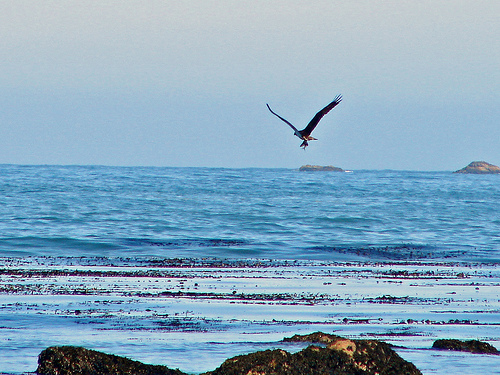<image>
Can you confirm if the bird is on the ocean? No. The bird is not positioned on the ocean. They may be near each other, but the bird is not supported by or resting on top of the ocean. Is there a bird on the water? No. The bird is not positioned on the water. They may be near each other, but the bird is not supported by or resting on top of the water. Where is the bird in relation to the water? Is it above the water? Yes. The bird is positioned above the water in the vertical space, higher up in the scene. 